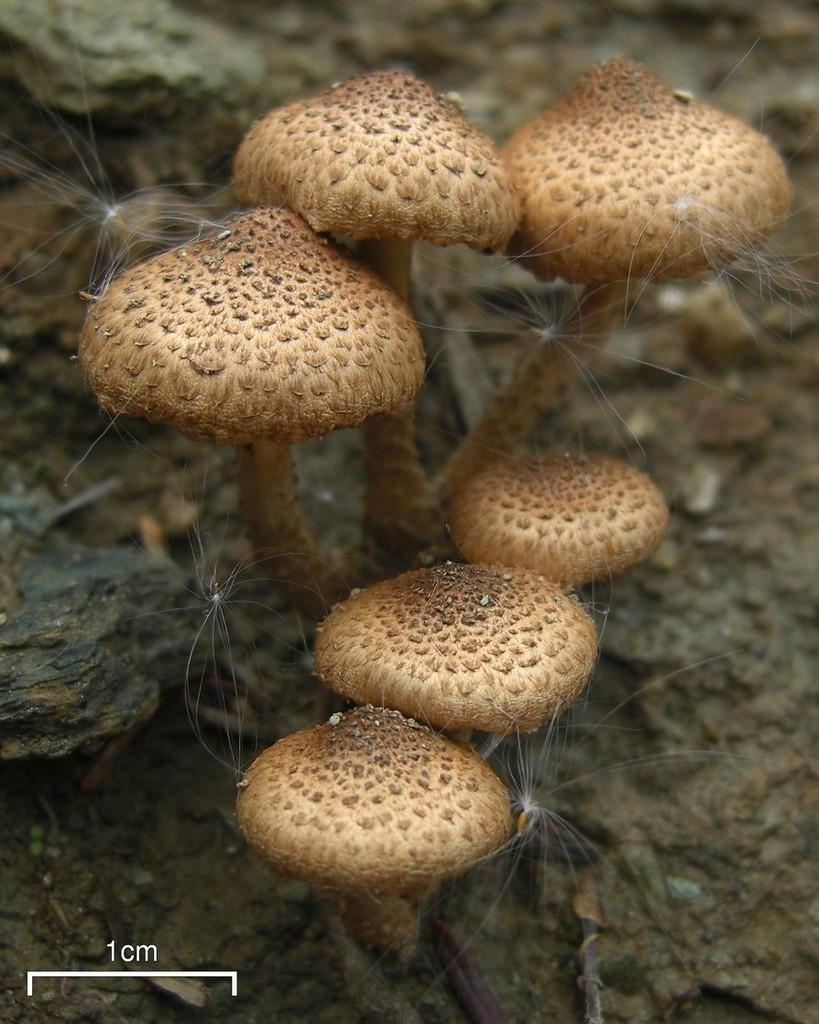What type of living organism can be seen in the image? There is a plant in the image. What is growing on the plant? The plant has mushrooms on it. Where is the plant located in the image? The plant is on the ground. What can be seen in the background of the image? There are stones on the ground in the background of the image. What type of grass is growing around the cat in the image? There is no cat present in the image, and therefore no grass growing around it. 